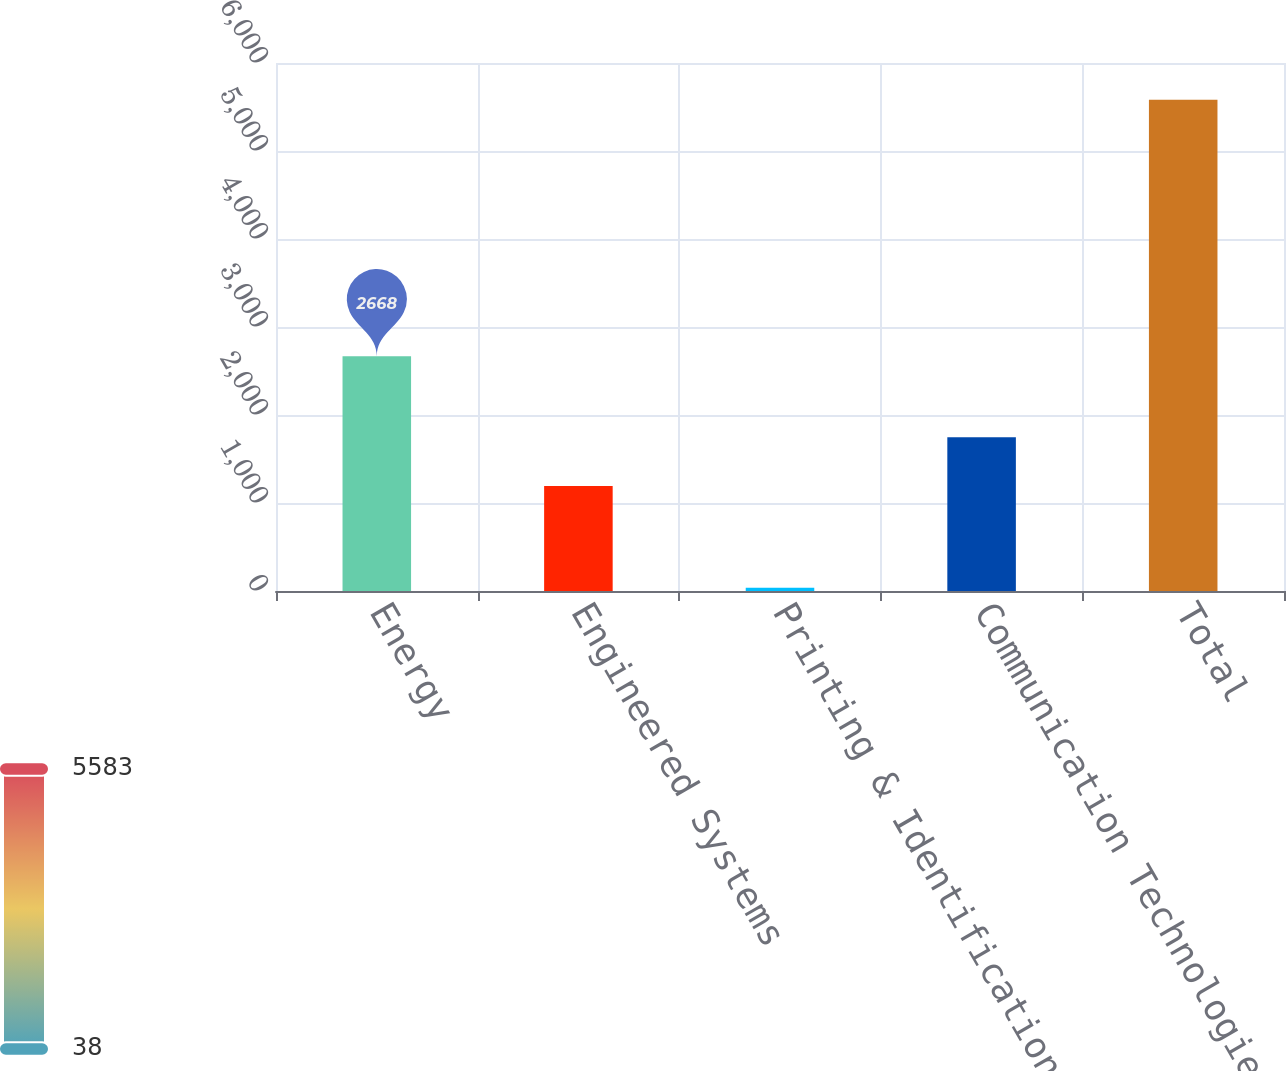<chart> <loc_0><loc_0><loc_500><loc_500><bar_chart><fcel>Energy<fcel>Engineered Systems<fcel>Printing & Identification<fcel>Communication Technologies<fcel>Total<nl><fcel>2668<fcel>1193<fcel>38<fcel>1747.5<fcel>5583<nl></chart> 